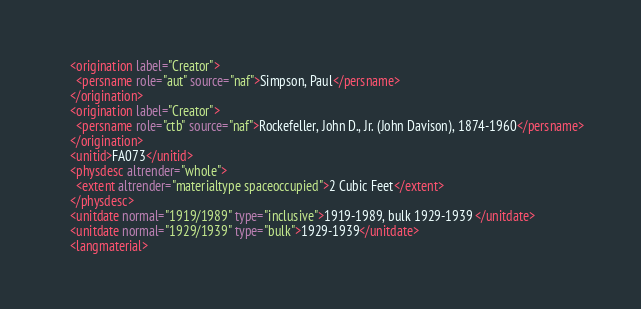Convert code to text. <code><loc_0><loc_0><loc_500><loc_500><_XML_>    <origination label="Creator">
      <persname role="aut" source="naf">Simpson, Paul</persname>
    </origination>
    <origination label="Creator">
      <persname role="ctb" source="naf">Rockefeller, John D., Jr. (John Davison), 1874-1960</persname>
    </origination>
    <unitid>FA073</unitid>
    <physdesc altrender="whole">
      <extent altrender="materialtype spaceoccupied">2 Cubic Feet</extent>
    </physdesc>
    <unitdate normal="1919/1989" type="inclusive">1919-1989, bulk 1929-1939 </unitdate>
    <unitdate normal="1929/1939" type="bulk">1929-1939</unitdate>
    <langmaterial></code> 